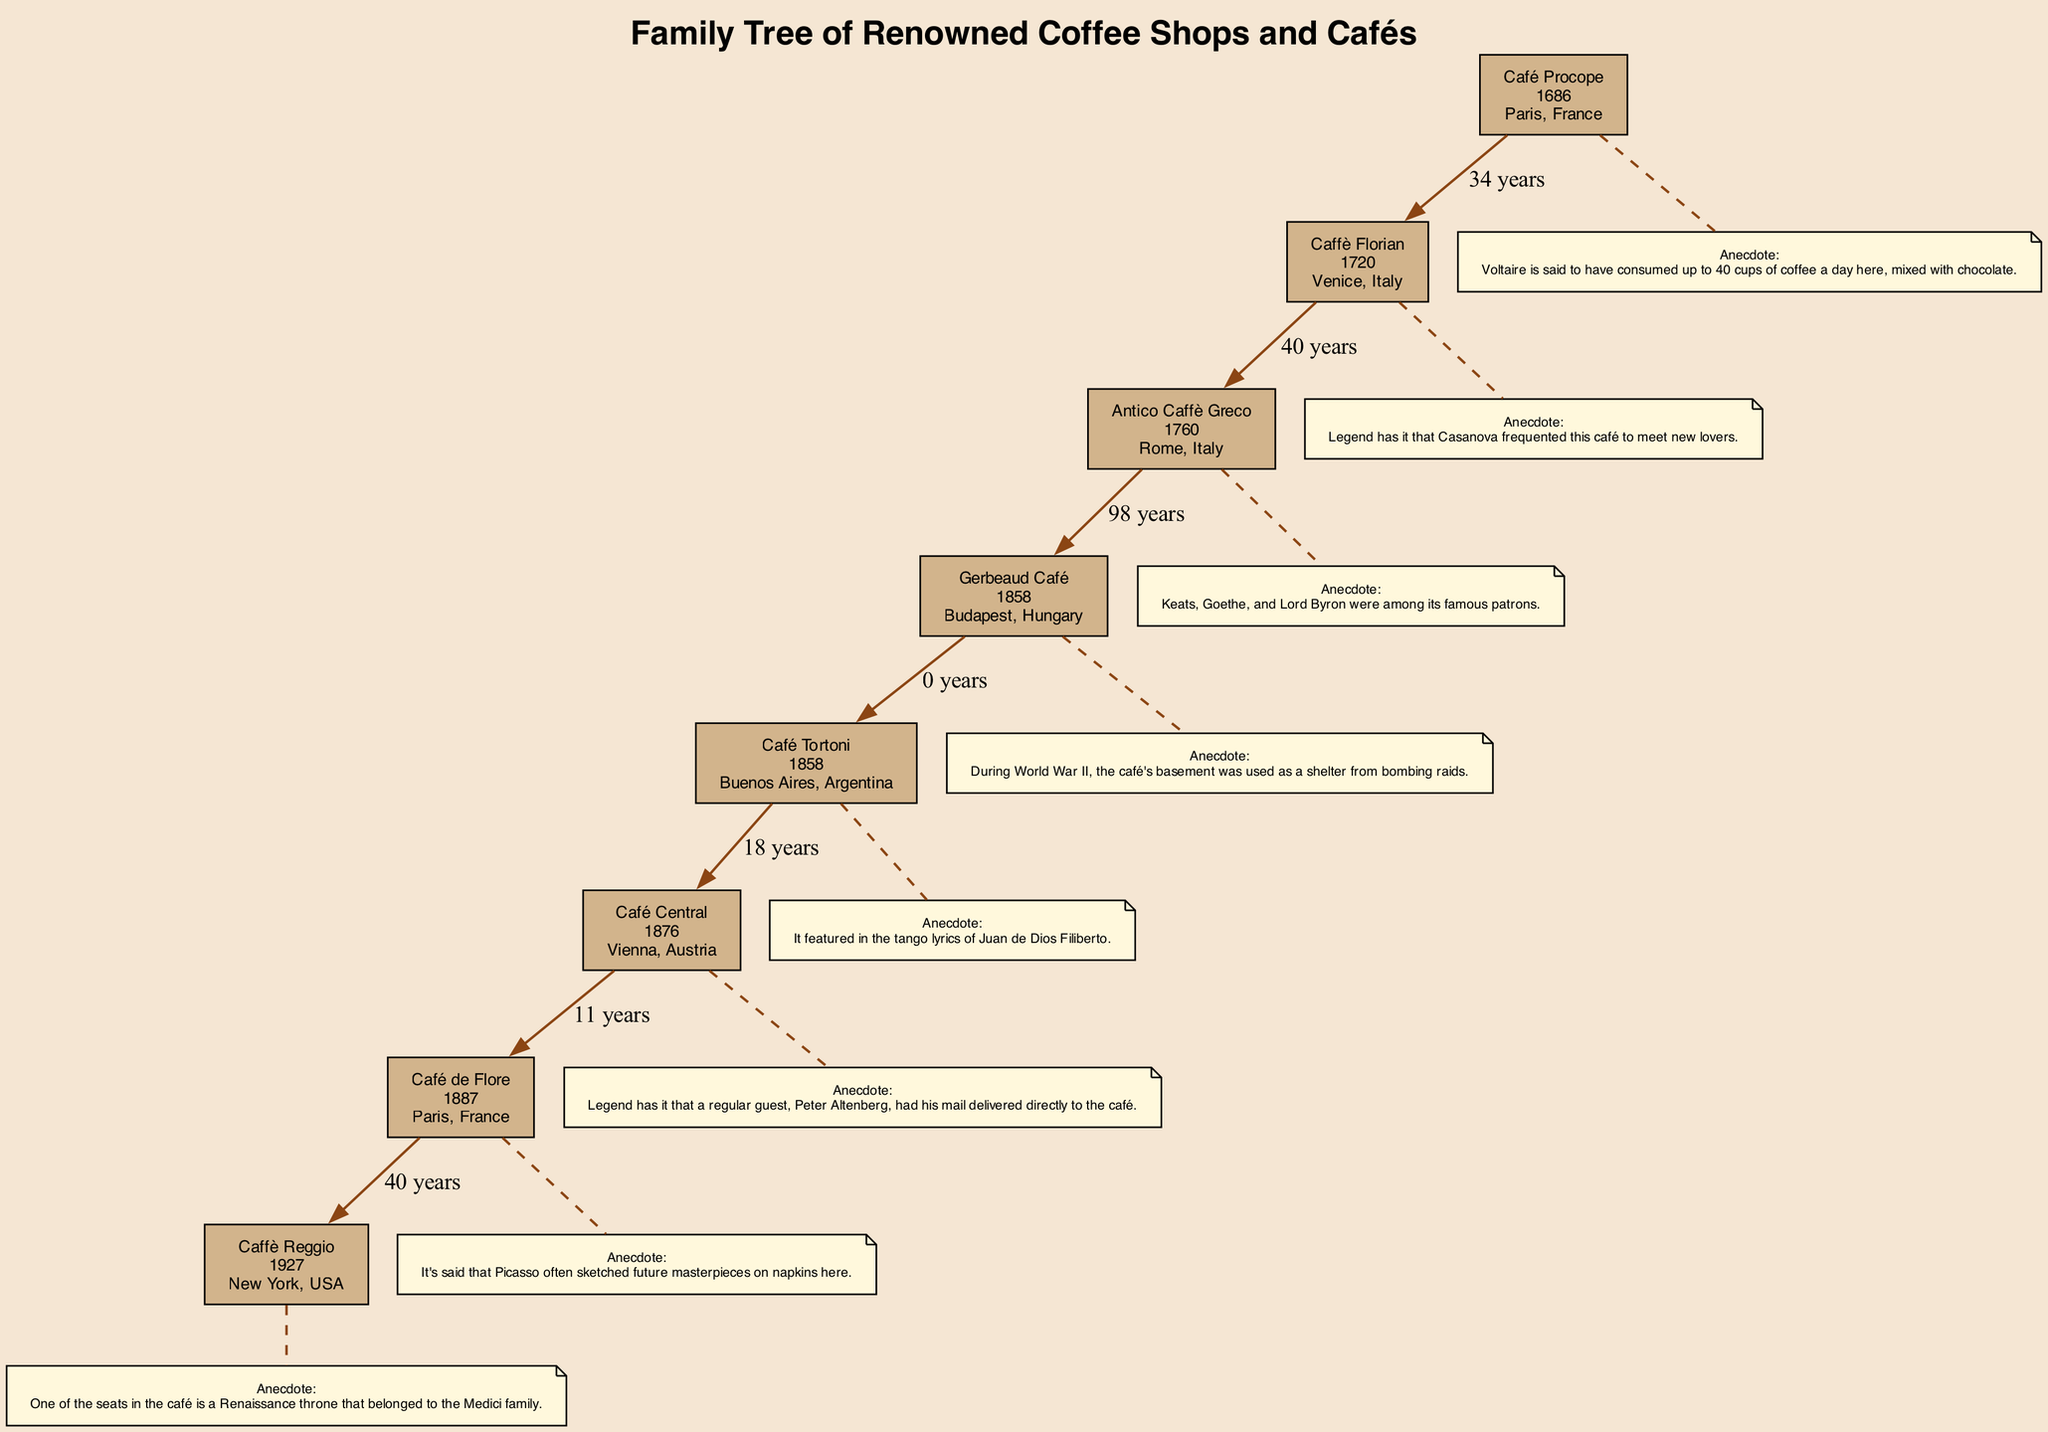What year was Caffè Florian founded? Caffè Florian is one of the earliest coffee houses listed in the diagram, with its establishment year prominently displayed as 1720.
Answer: 1720 How many years after Café Procope was Antico Caffè Greco founded? Café Procope was founded in 1686 and Antico Caffè Greco in 1760. The difference in years is calculated as 1760 - 1686, which equals 74 years.
Answer: 74 years What is the significance of Caffè Reggio? Each café's significance is listed, and for Caffè Reggio, it states that it introduced the cappuccino to America, highlighted in the diagram.
Answer: Introduced the cappuccino to America Which café was frequented by Casanova? According to the anecdote attached to Caffè Florian, it is mentioned that Casanova frequently visited this café for romantic encounters.
Answer: Caffè Florian Which café has an association with the Medici family? The explanation in the diagram notes that one of the seats in Caffè Reggio is a Renaissance throne that belonged to the Medici family, directly linking this café to the historical figure.
Answer: Caffè Reggio What is the founding year of Café Central? The founding year for Café Central is displayed in the node, which indicates it was established in 1876 according to the data provided in the diagram.
Answer: 1876 Which café is famously associated with existentialists? The significance of Café de Flore indicates it was a favorite among existentialists like Jean-Paul Sartre and Simone de Beauvoir, drawing a clear association with this particular café.
Answer: Café de Flore What common feature do both Gerbeaud Café and Café Tortoni share? Both cafés were founded in the same year, 1858, which can be observed when comparing their founding years in the diagram.
Answer: 1858 What notable anecdote is associated with Café Central? The diagram notes that Peter Altenberg was a regular patron who had his mail delivered directly to Café Central, highlighting a unique aspect of its history.
Answer: Mail delivery to the café 